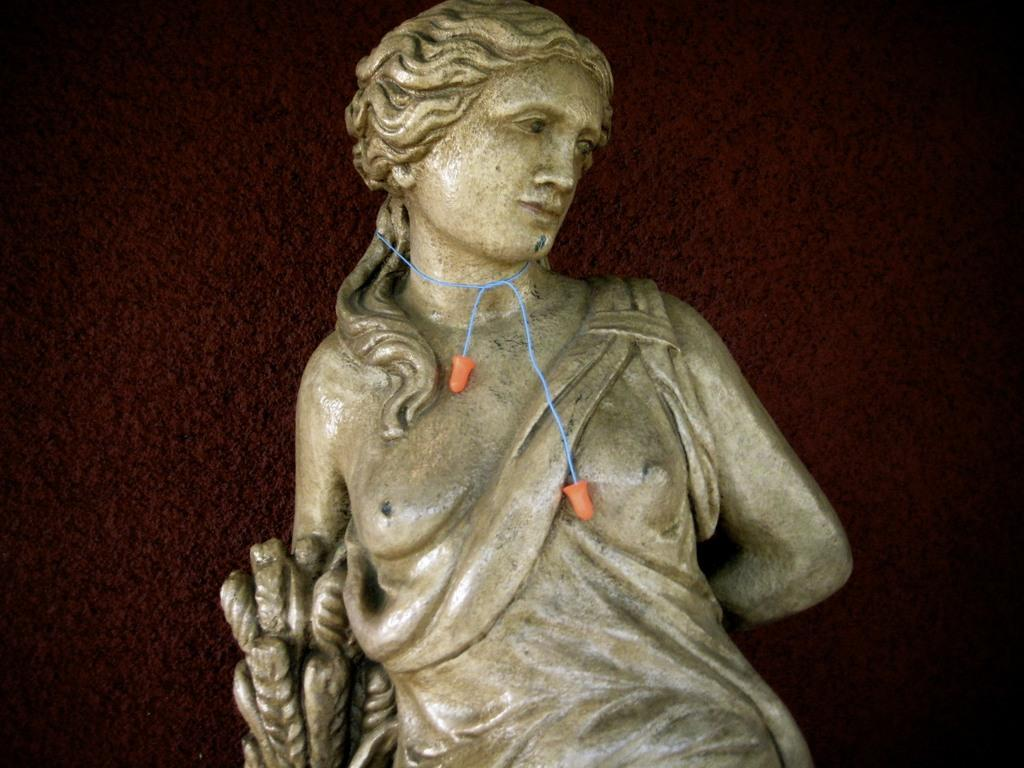What is the main subject of the image? There is a sculpture of a woman in the image. Can you describe the sculpture in more detail? Unfortunately, the provided facts do not offer any additional details about the sculpture. Is the sculpture of a woman located indoors or outdoors? The location of the sculpture is not mentioned in the provided facts. How many toads are sitting on the quill in the image? There are no toads or quills present in the image; it features a sculpture of a woman. 